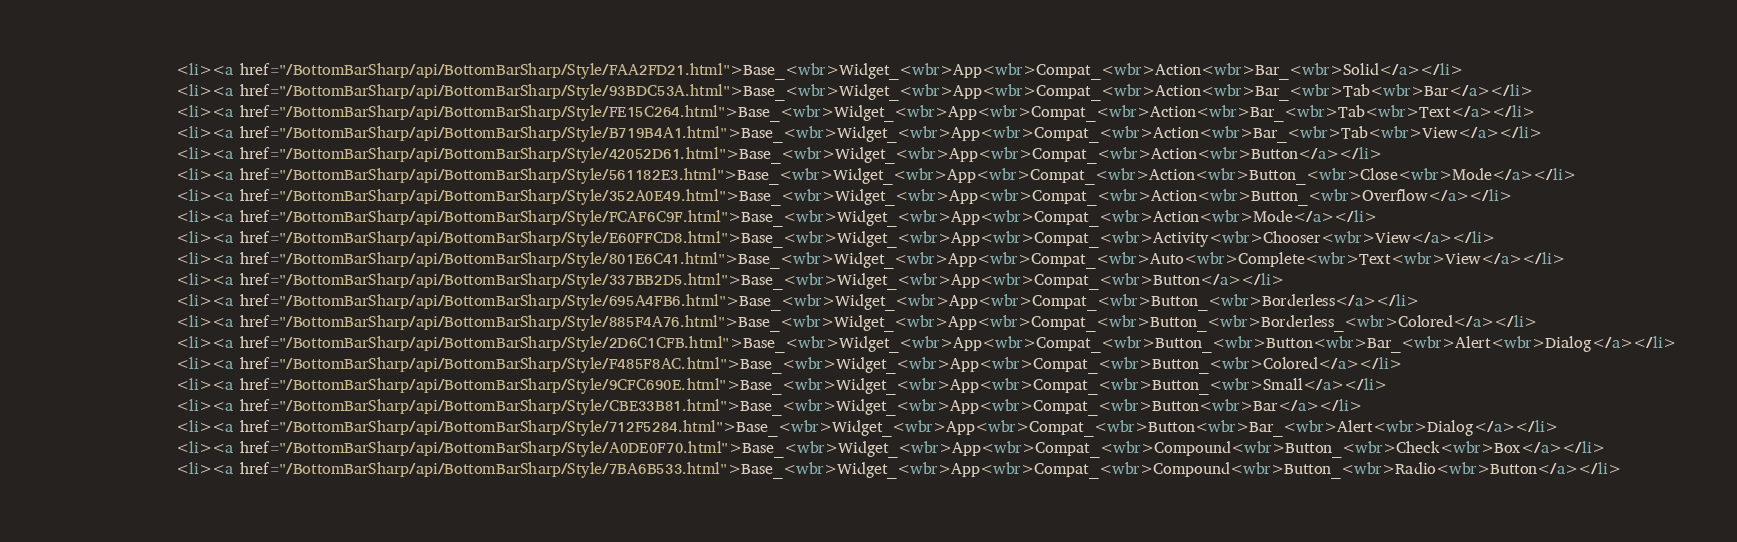Convert code to text. <code><loc_0><loc_0><loc_500><loc_500><_HTML_>				<li><a href="/BottomBarSharp/api/BottomBarSharp/Style/FAA2FD21.html">Base_<wbr>Widget_<wbr>App<wbr>Compat_<wbr>Action<wbr>Bar_<wbr>Solid</a></li>
				<li><a href="/BottomBarSharp/api/BottomBarSharp/Style/93BDC53A.html">Base_<wbr>Widget_<wbr>App<wbr>Compat_<wbr>Action<wbr>Bar_<wbr>Tab<wbr>Bar</a></li>
				<li><a href="/BottomBarSharp/api/BottomBarSharp/Style/FE15C264.html">Base_<wbr>Widget_<wbr>App<wbr>Compat_<wbr>Action<wbr>Bar_<wbr>Tab<wbr>Text</a></li>
				<li><a href="/BottomBarSharp/api/BottomBarSharp/Style/B719B4A1.html">Base_<wbr>Widget_<wbr>App<wbr>Compat_<wbr>Action<wbr>Bar_<wbr>Tab<wbr>View</a></li>
				<li><a href="/BottomBarSharp/api/BottomBarSharp/Style/42052D61.html">Base_<wbr>Widget_<wbr>App<wbr>Compat_<wbr>Action<wbr>Button</a></li>
				<li><a href="/BottomBarSharp/api/BottomBarSharp/Style/561182E3.html">Base_<wbr>Widget_<wbr>App<wbr>Compat_<wbr>Action<wbr>Button_<wbr>Close<wbr>Mode</a></li>
				<li><a href="/BottomBarSharp/api/BottomBarSharp/Style/352A0E49.html">Base_<wbr>Widget_<wbr>App<wbr>Compat_<wbr>Action<wbr>Button_<wbr>Overflow</a></li>
				<li><a href="/BottomBarSharp/api/BottomBarSharp/Style/FCAF6C9F.html">Base_<wbr>Widget_<wbr>App<wbr>Compat_<wbr>Action<wbr>Mode</a></li>
				<li><a href="/BottomBarSharp/api/BottomBarSharp/Style/E60FFCD8.html">Base_<wbr>Widget_<wbr>App<wbr>Compat_<wbr>Activity<wbr>Chooser<wbr>View</a></li>
				<li><a href="/BottomBarSharp/api/BottomBarSharp/Style/801E6C41.html">Base_<wbr>Widget_<wbr>App<wbr>Compat_<wbr>Auto<wbr>Complete<wbr>Text<wbr>View</a></li>
				<li><a href="/BottomBarSharp/api/BottomBarSharp/Style/337BB2D5.html">Base_<wbr>Widget_<wbr>App<wbr>Compat_<wbr>Button</a></li>
				<li><a href="/BottomBarSharp/api/BottomBarSharp/Style/695A4FB6.html">Base_<wbr>Widget_<wbr>App<wbr>Compat_<wbr>Button_<wbr>Borderless</a></li>
				<li><a href="/BottomBarSharp/api/BottomBarSharp/Style/885F4A76.html">Base_<wbr>Widget_<wbr>App<wbr>Compat_<wbr>Button_<wbr>Borderless_<wbr>Colored</a></li>
				<li><a href="/BottomBarSharp/api/BottomBarSharp/Style/2D6C1CFB.html">Base_<wbr>Widget_<wbr>App<wbr>Compat_<wbr>Button_<wbr>Button<wbr>Bar_<wbr>Alert<wbr>Dialog</a></li>
				<li><a href="/BottomBarSharp/api/BottomBarSharp/Style/F485F8AC.html">Base_<wbr>Widget_<wbr>App<wbr>Compat_<wbr>Button_<wbr>Colored</a></li>
				<li><a href="/BottomBarSharp/api/BottomBarSharp/Style/9CFC690E.html">Base_<wbr>Widget_<wbr>App<wbr>Compat_<wbr>Button_<wbr>Small</a></li>
				<li><a href="/BottomBarSharp/api/BottomBarSharp/Style/CBE33B81.html">Base_<wbr>Widget_<wbr>App<wbr>Compat_<wbr>Button<wbr>Bar</a></li>
				<li><a href="/BottomBarSharp/api/BottomBarSharp/Style/712F5284.html">Base_<wbr>Widget_<wbr>App<wbr>Compat_<wbr>Button<wbr>Bar_<wbr>Alert<wbr>Dialog</a></li>
				<li><a href="/BottomBarSharp/api/BottomBarSharp/Style/A0DE0F70.html">Base_<wbr>Widget_<wbr>App<wbr>Compat_<wbr>Compound<wbr>Button_<wbr>Check<wbr>Box</a></li>
				<li><a href="/BottomBarSharp/api/BottomBarSharp/Style/7BA6B533.html">Base_<wbr>Widget_<wbr>App<wbr>Compat_<wbr>Compound<wbr>Button_<wbr>Radio<wbr>Button</a></li></code> 